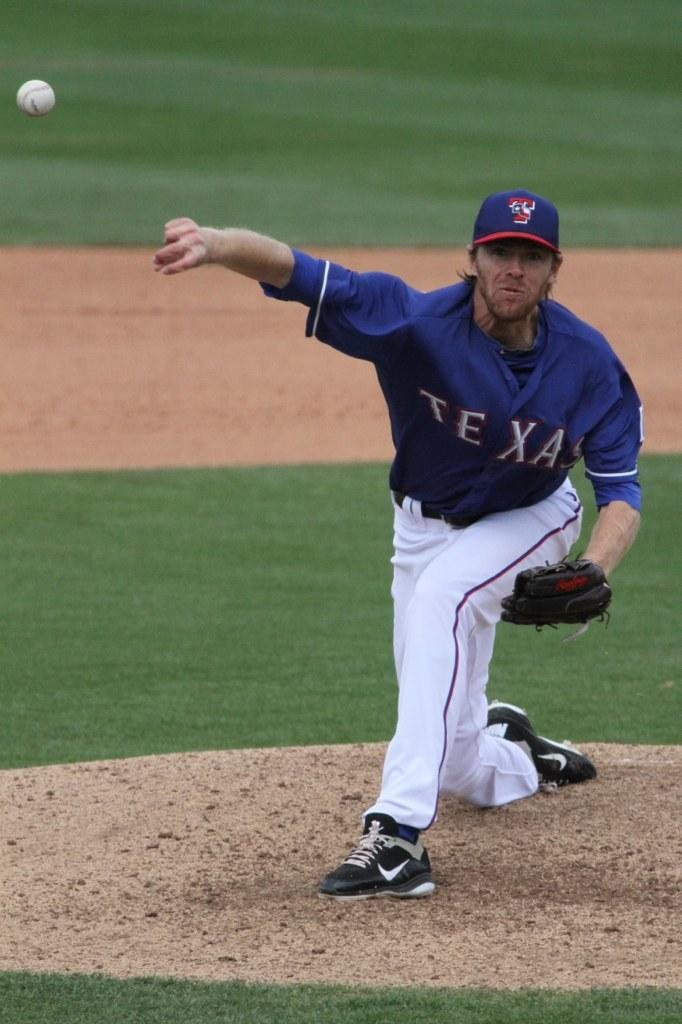<image>
Provide a brief description of the given image. A man with a Jersey that says Texas throwing a baseball 